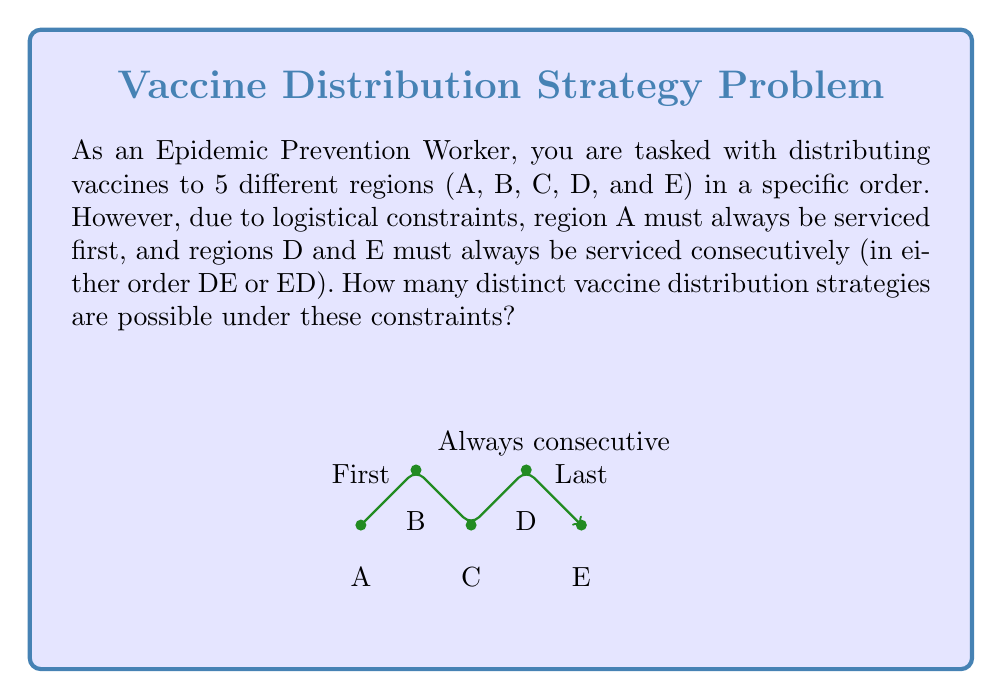Could you help me with this problem? Let's approach this step-by-step using permutation groups:

1) We start with 5! = 120 possible permutations of 5 regions.

2) However, we have several constraints:
   a) A must be first
   b) D and E must be consecutive

3) To account for A being first, we can consider it fixed and permute the remaining 4 regions. This reduces our options to 4! = 24.

4) Now, we need to consider D and E as a single unit, let's call it (DE). This further reduces our problem to permuting 3 elements: B, C, and (DE).

5) The number of permutations of 3 elements is 3! = 6.

6) However, for each of these 6 permutations, (DE) can be arranged in 2 ways: DE or ED.

7) Therefore, the total number of distinct strategies is:

   $$ 6 \times 2 = 12 $$

This can also be represented using cycle notation in group theory:

$$ |\{e, (DE)\}| \times |S_3| = 2 \times 6 = 12 $$

Where $\{e, (DE)\}$ represents the group of permutations of D and E, and $S_3$ is the symmetric group on 3 elements (B, C, and (DE)).
Answer: 12 